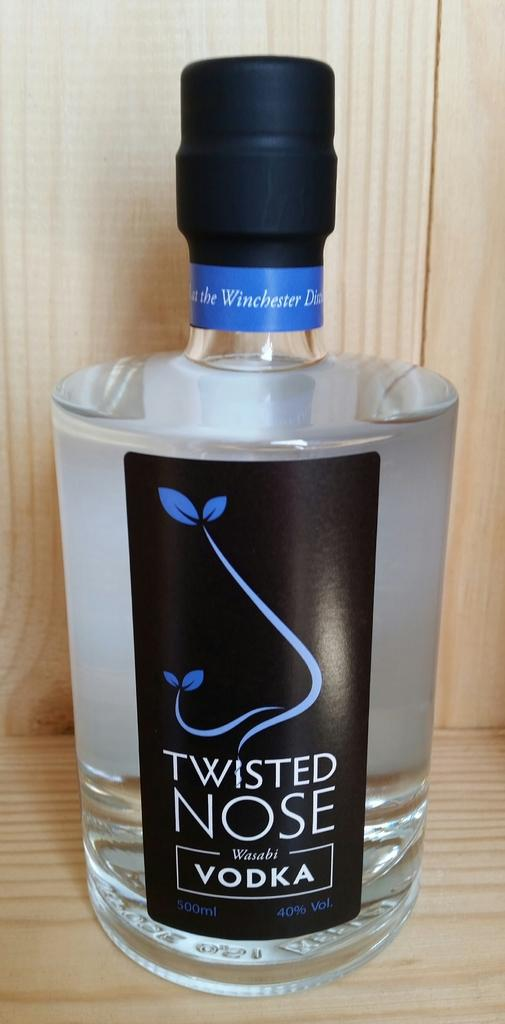<image>
Give a short and clear explanation of the subsequent image. A bottle of Twisted Nose Vodka sits on a wooden shelf. 